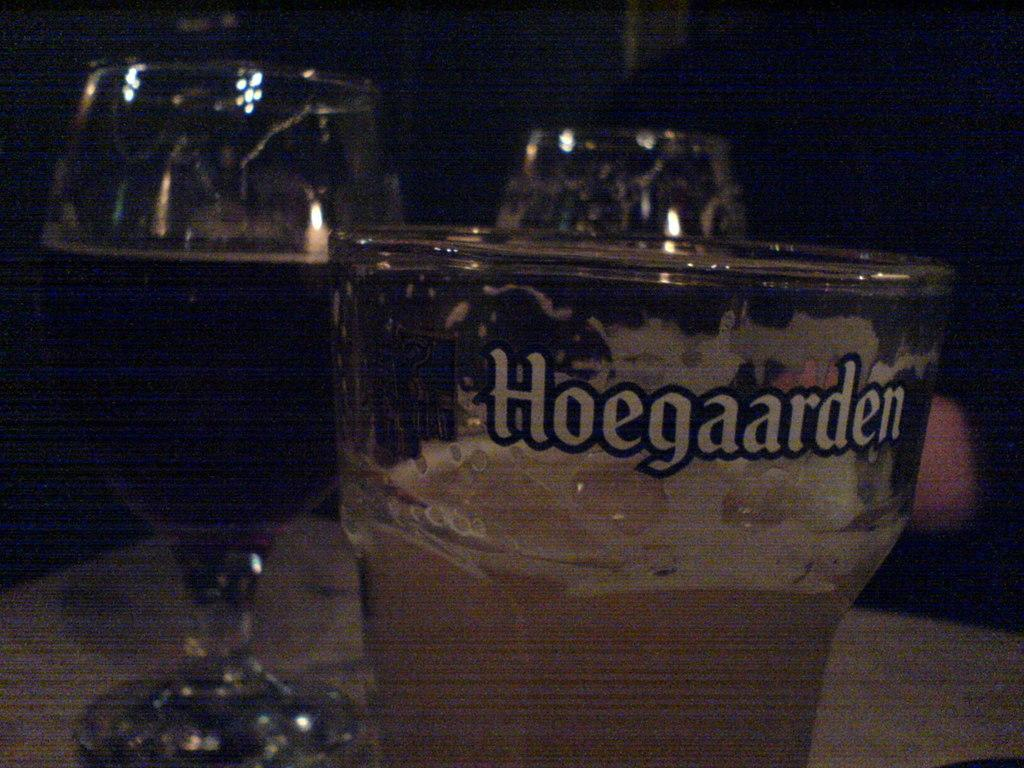<image>
Offer a succinct explanation of the picture presented. A glass with a drink in it and Hoegaarden on the side of the glass. 